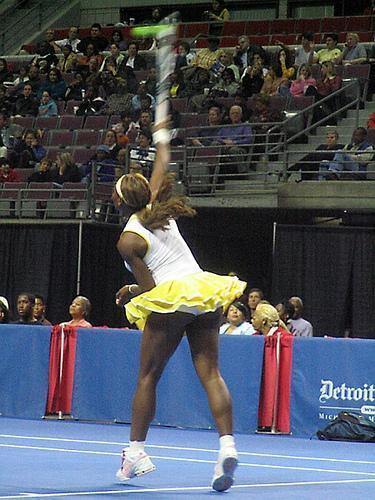How many players are in this picture?
Give a very brief answer. 1. How many people are watching football player?
Give a very brief answer. 0. 